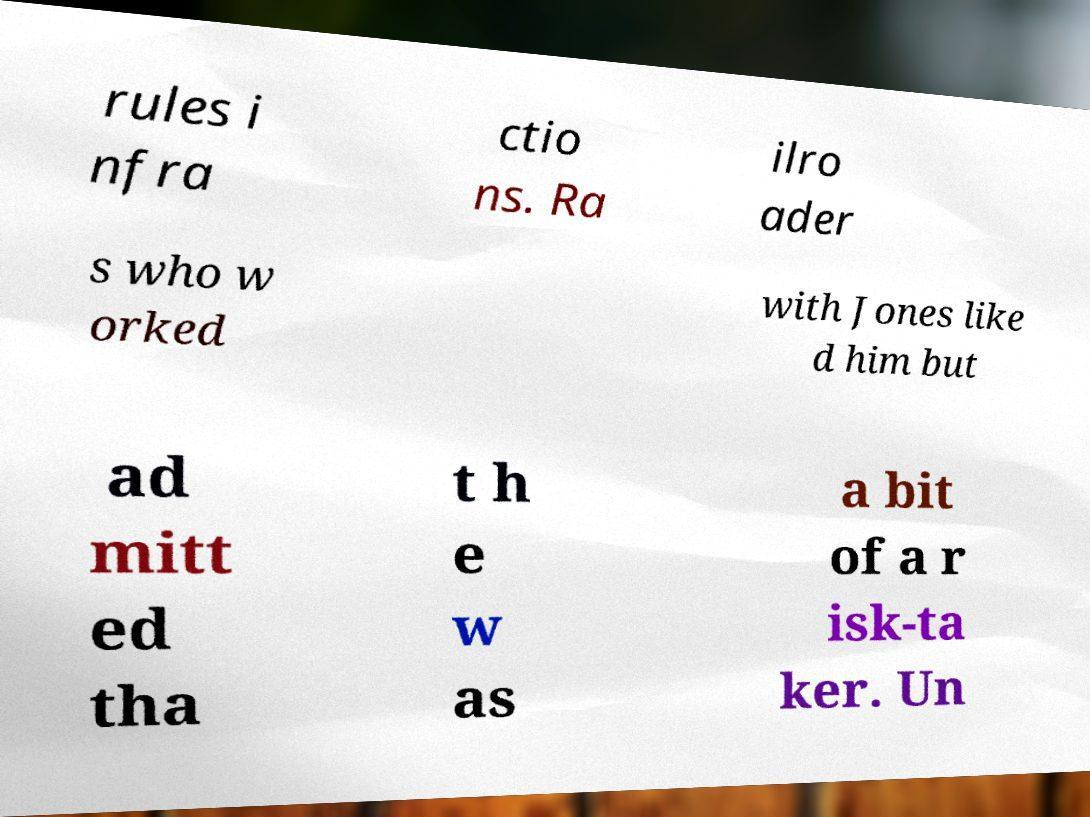Could you assist in decoding the text presented in this image and type it out clearly? rules i nfra ctio ns. Ra ilro ader s who w orked with Jones like d him but ad mitt ed tha t h e w as a bit of a r isk-ta ker. Un 